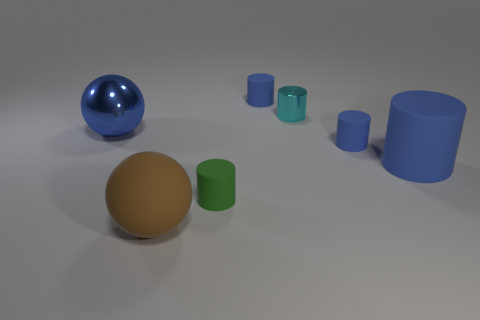Subtract all gray cubes. How many blue cylinders are left? 3 Subtract all blue cylinders. How many cylinders are left? 2 Subtract all green cylinders. How many cylinders are left? 4 Add 1 big blue matte things. How many objects exist? 8 Subtract all cylinders. How many objects are left? 2 Subtract all green cylinders. Subtract all gray balls. How many cylinders are left? 4 Subtract all large brown objects. Subtract all tiny cyan cylinders. How many objects are left? 5 Add 6 metallic cylinders. How many metallic cylinders are left? 7 Add 7 yellow metallic cubes. How many yellow metallic cubes exist? 7 Subtract 0 red cylinders. How many objects are left? 7 